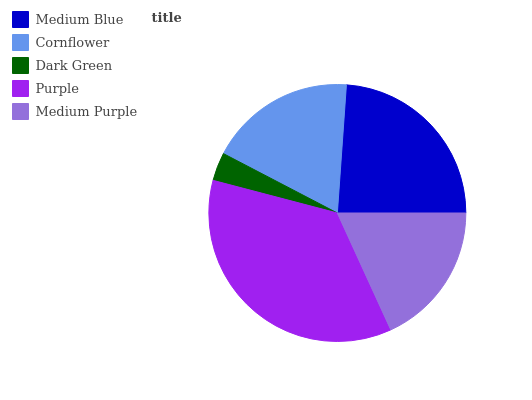Is Dark Green the minimum?
Answer yes or no. Yes. Is Purple the maximum?
Answer yes or no. Yes. Is Cornflower the minimum?
Answer yes or no. No. Is Cornflower the maximum?
Answer yes or no. No. Is Medium Blue greater than Cornflower?
Answer yes or no. Yes. Is Cornflower less than Medium Blue?
Answer yes or no. Yes. Is Cornflower greater than Medium Blue?
Answer yes or no. No. Is Medium Blue less than Cornflower?
Answer yes or no. No. Is Cornflower the high median?
Answer yes or no. Yes. Is Cornflower the low median?
Answer yes or no. Yes. Is Medium Purple the high median?
Answer yes or no. No. Is Medium Purple the low median?
Answer yes or no. No. 